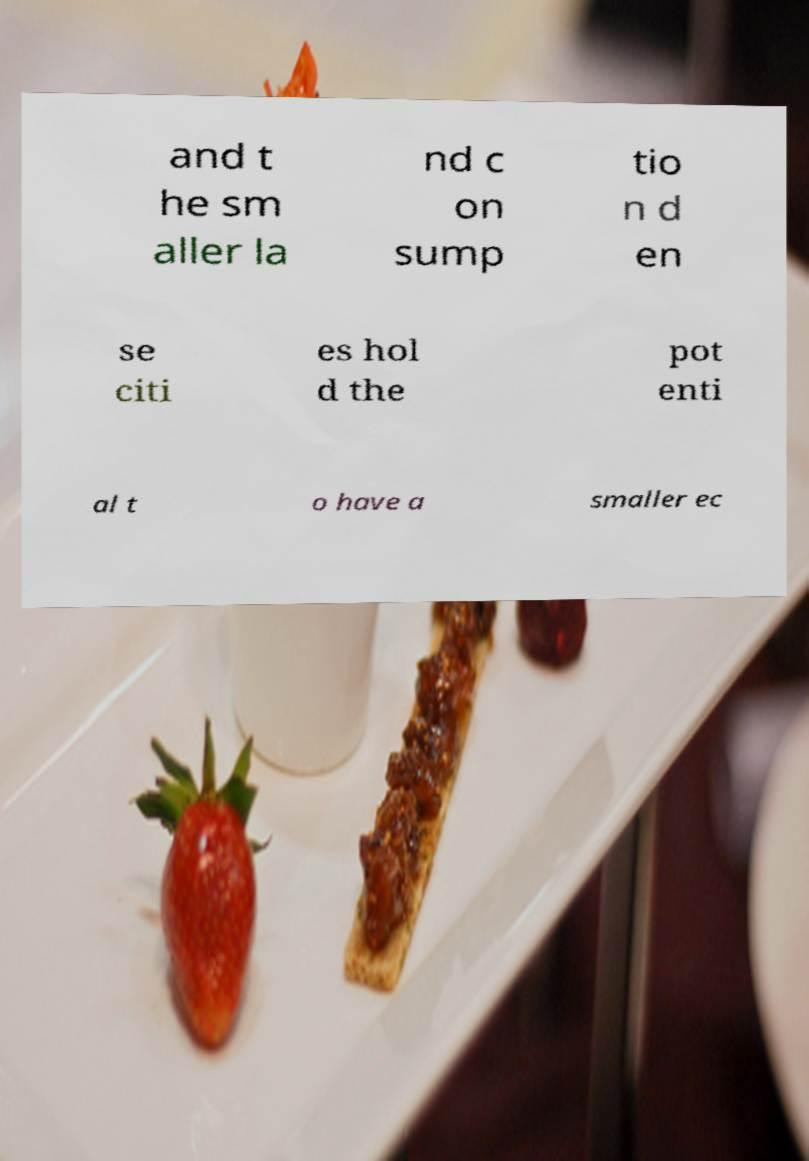Can you read and provide the text displayed in the image?This photo seems to have some interesting text. Can you extract and type it out for me? and t he sm aller la nd c on sump tio n d en se citi es hol d the pot enti al t o have a smaller ec 